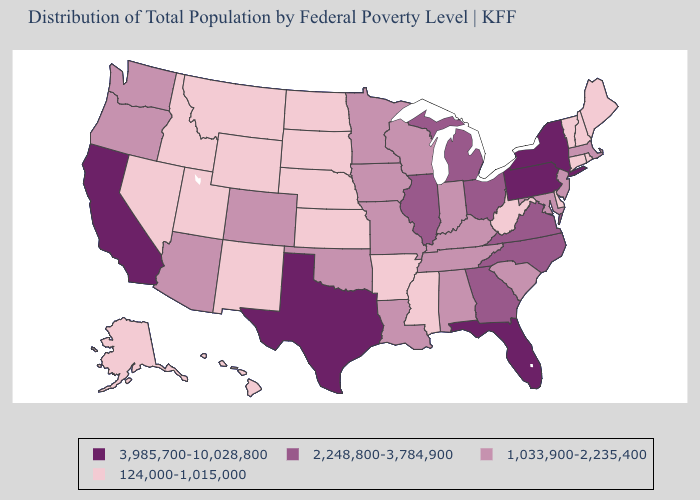What is the lowest value in the Northeast?
Keep it brief. 124,000-1,015,000. Does Arkansas have the lowest value in the South?
Answer briefly. Yes. Name the states that have a value in the range 2,248,800-3,784,900?
Concise answer only. Georgia, Illinois, Michigan, North Carolina, Ohio, Virginia. What is the lowest value in states that border Oregon?
Give a very brief answer. 124,000-1,015,000. What is the lowest value in the USA?
Answer briefly. 124,000-1,015,000. Among the states that border Arizona , does Colorado have the highest value?
Be succinct. No. Is the legend a continuous bar?
Concise answer only. No. Name the states that have a value in the range 124,000-1,015,000?
Quick response, please. Alaska, Arkansas, Connecticut, Delaware, Hawaii, Idaho, Kansas, Maine, Mississippi, Montana, Nebraska, Nevada, New Hampshire, New Mexico, North Dakota, Rhode Island, South Dakota, Utah, Vermont, West Virginia, Wyoming. Name the states that have a value in the range 2,248,800-3,784,900?
Keep it brief. Georgia, Illinois, Michigan, North Carolina, Ohio, Virginia. Does California have the highest value in the West?
Concise answer only. Yes. What is the value of Arkansas?
Answer briefly. 124,000-1,015,000. Name the states that have a value in the range 2,248,800-3,784,900?
Quick response, please. Georgia, Illinois, Michigan, North Carolina, Ohio, Virginia. Does the first symbol in the legend represent the smallest category?
Write a very short answer. No. How many symbols are there in the legend?
Give a very brief answer. 4. What is the value of Delaware?
Concise answer only. 124,000-1,015,000. 